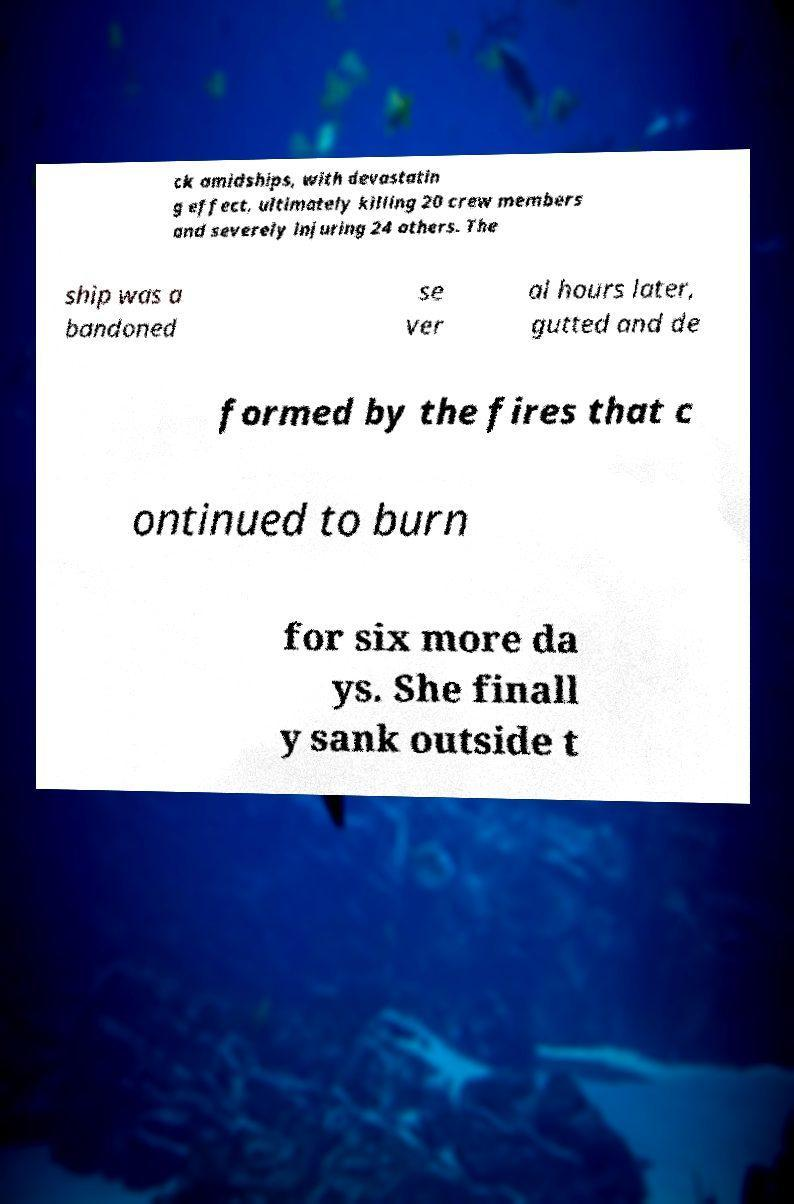Could you assist in decoding the text presented in this image and type it out clearly? ck amidships, with devastatin g effect, ultimately killing 20 crew members and severely injuring 24 others. The ship was a bandoned se ver al hours later, gutted and de formed by the fires that c ontinued to burn for six more da ys. She finall y sank outside t 